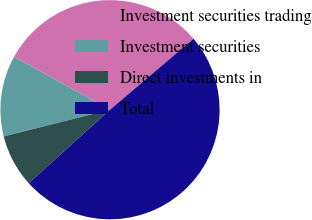Convert chart. <chart><loc_0><loc_0><loc_500><loc_500><pie_chart><fcel>Investment securities trading<fcel>Investment securities<fcel>Direct investments in<fcel>Total<nl><fcel>30.76%<fcel>11.95%<fcel>7.78%<fcel>49.51%<nl></chart> 